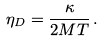<formula> <loc_0><loc_0><loc_500><loc_500>\eta _ { D } = \frac { \kappa } { 2 M T } \, .</formula> 